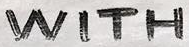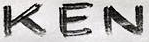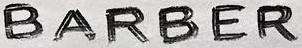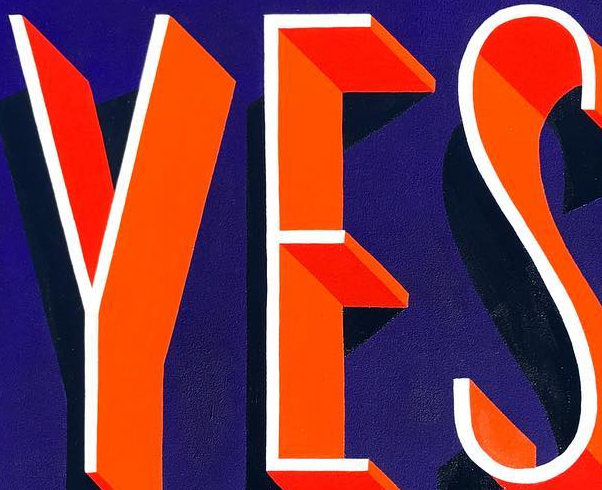Identify the words shown in these images in order, separated by a semicolon. WITH; KEN; BARBER; YES 